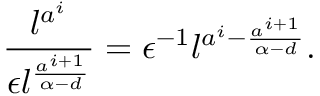Convert formula to latex. <formula><loc_0><loc_0><loc_500><loc_500>\frac { l ^ { a ^ { i } } } { \epsilon l ^ { \frac { a ^ { i + 1 } } { \alpha - d } } } = \epsilon ^ { - 1 } l ^ { a ^ { i } - \frac { a ^ { i + 1 } } { \alpha - d } } .</formula> 